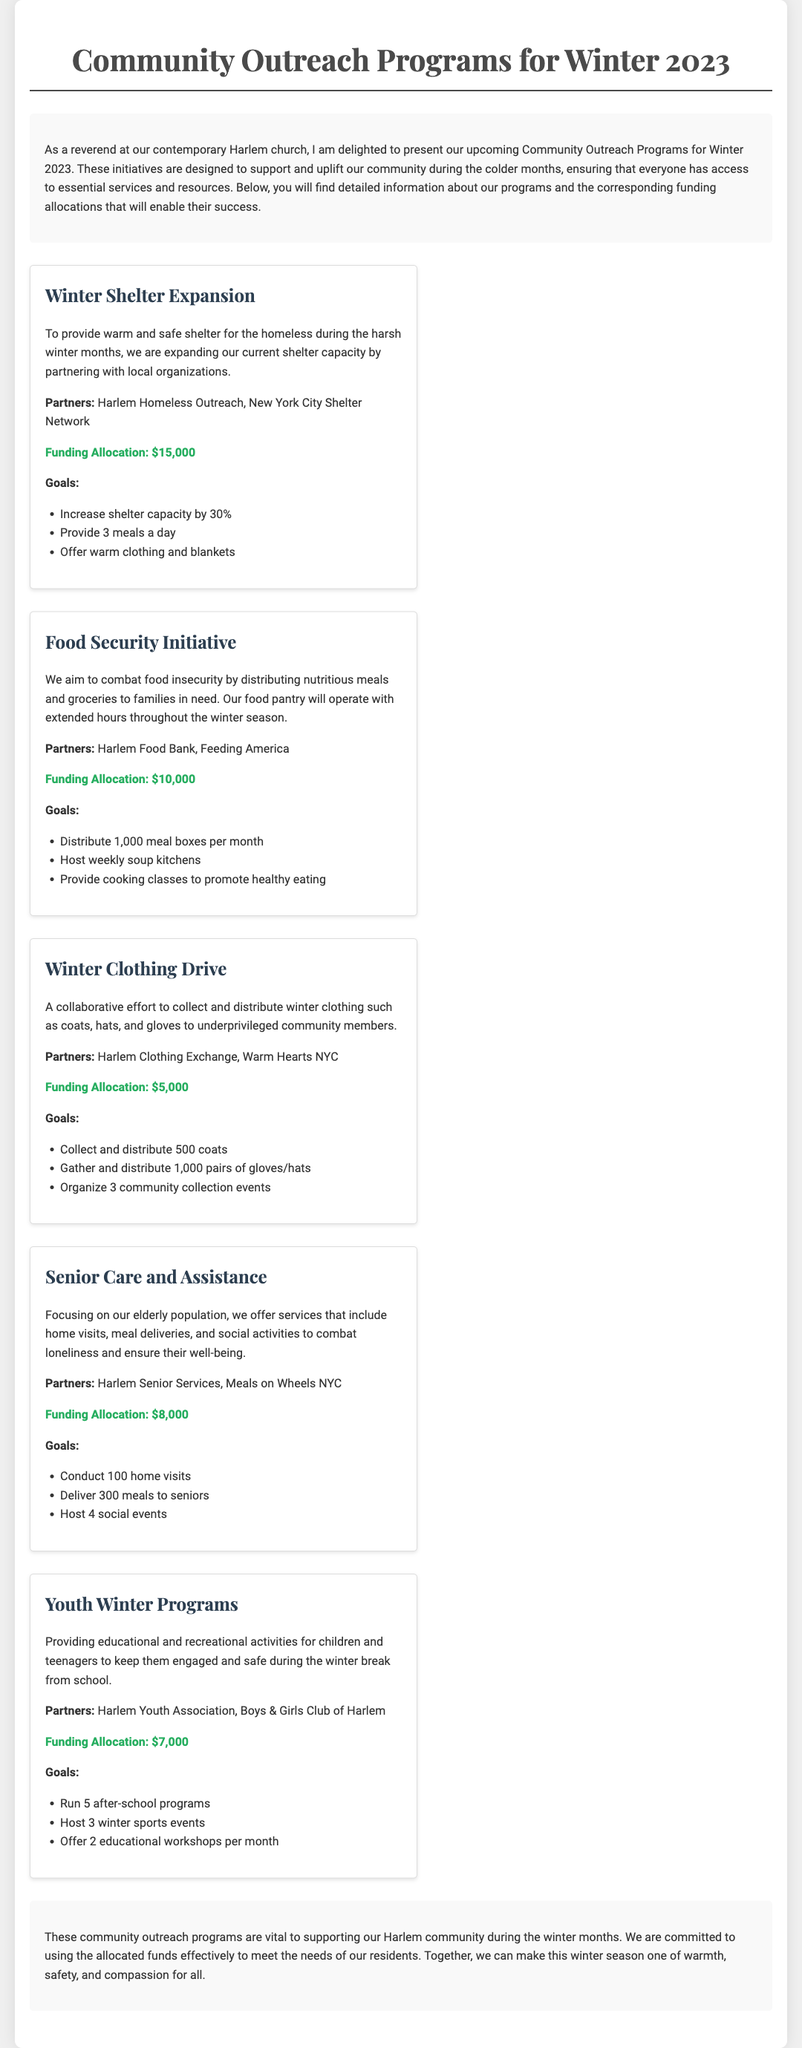What is the total funding allocated for the Winter Shelter Expansion? The funding allocated for the Winter Shelter Expansion is stated directly in the document as $15,000.
Answer: $15,000 Who are the partners for the Food Security Initiative? The partners for the Food Security Initiative are listed in the program details section.
Answer: Harlem Food Bank, Feeding America How many meal boxes does the Food Security Initiative aim to distribute per month? The document specifies that the initiative aims to distribute 1,000 meal boxes per month.
Answer: 1,000 What is the total funding allocation for all programs combined? The total funding allocation can be found by adding all the individual allocations: $15,000 + $10,000 + $5,000 + $8,000 + $7,000 = $45,000.
Answer: $45,000 What is one goal of the Winter Clothing Drive? The goals of the Winter Clothing Drive include several items, one being to collect and distribute 500 coats.
Answer: Collect and distribute 500 coats How many social events does the Senior Care and Assistance program plan to host? The program details indicate that the goal is to host 4 social events for seniors.
Answer: 4 What is the purpose of the Youth Winter Programs? The document clearly outlines that its purpose is to provide educational and recreational activities for children and teenagers during winter break.
Answer: Provide educational and recreational activities How much funding is allocated for the Winter Clothing Drive? The allocated funding for the Winter Clothing Drive is specified in the document.
Answer: $5,000 What percentage of capacity increase does the Winter Shelter Expansion aim for? The document states that the goal is to increase shelter capacity by 30%.
Answer: 30% 